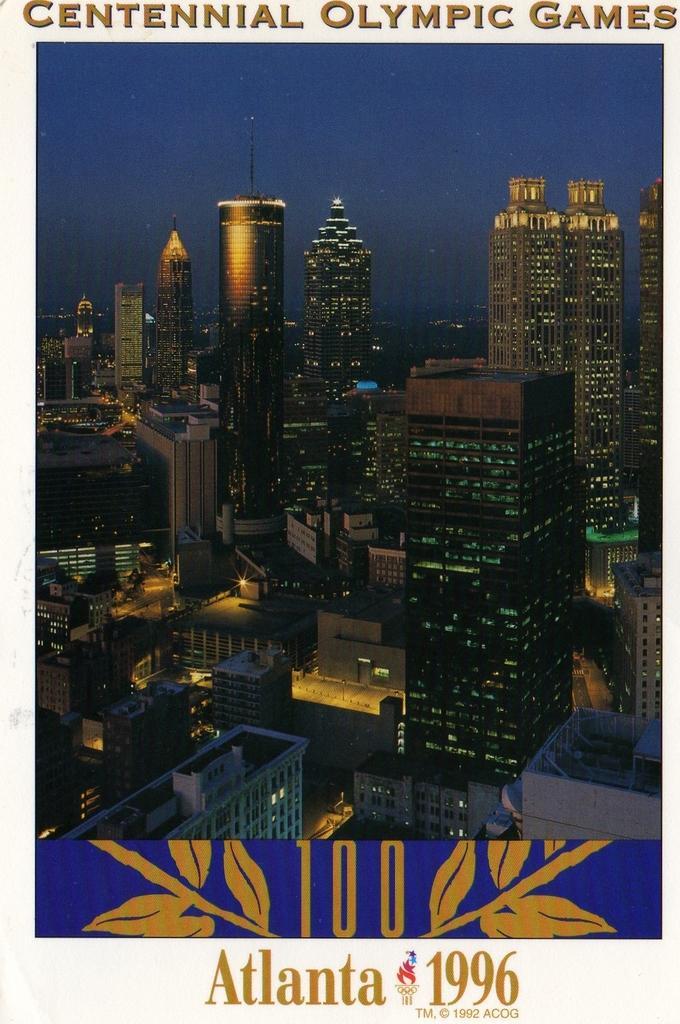In one or two sentences, can you explain what this image depicts? In this image I can see a poster in which I can see number of buildings, lights and the dark sky in the background. I can see something is written on the poster. 